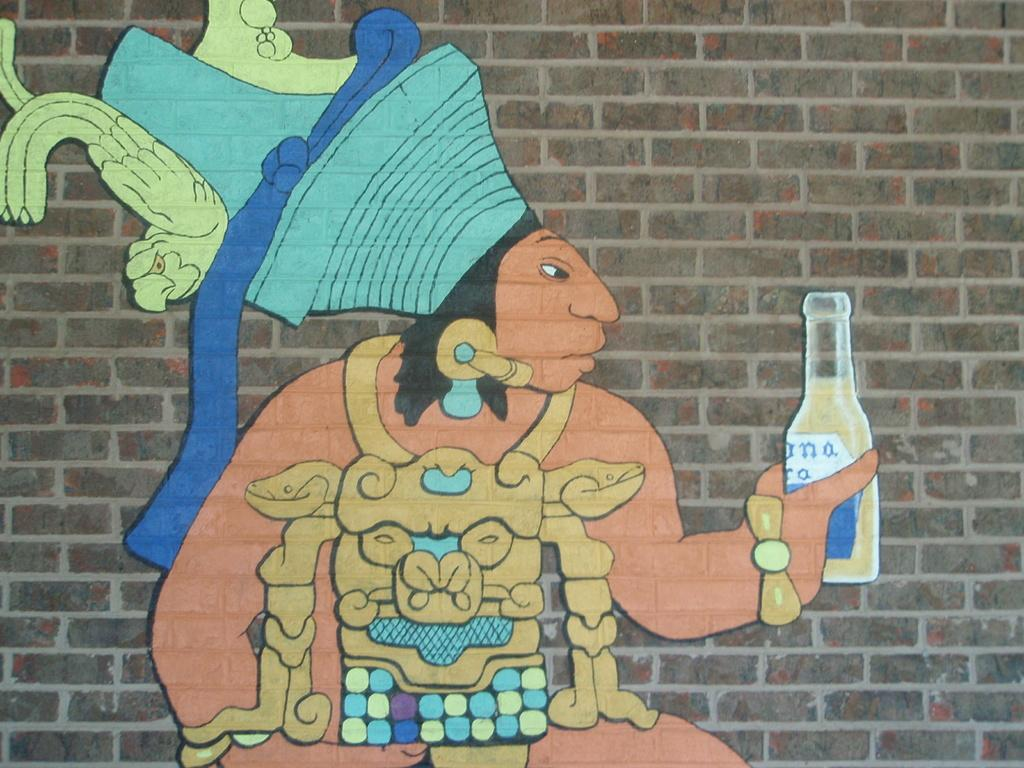<image>
Give a short and clear explanation of the subsequent image. A graffiti art image on a brick wall of a south american mayan type figure holding a corona. 